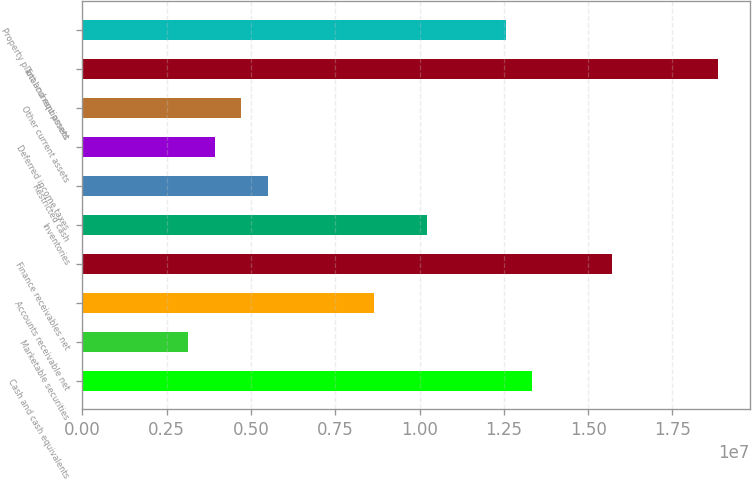Convert chart to OTSL. <chart><loc_0><loc_0><loc_500><loc_500><bar_chart><fcel>Cash and cash equivalents<fcel>Marketable securities<fcel>Accounts receivable net<fcel>Finance receivables net<fcel>Inventories<fcel>Restricted cash<fcel>Deferred income taxes<fcel>Other current assets<fcel>Total current assets<fcel>Property plant and equipment<nl><fcel>1.33472e+07<fcel>3.14315e+06<fcel>8.63766e+06<fcel>1.5702e+07<fcel>1.02075e+07<fcel>5.49794e+06<fcel>3.92808e+06<fcel>4.71301e+06<fcel>1.88417e+07<fcel>1.25623e+07<nl></chart> 